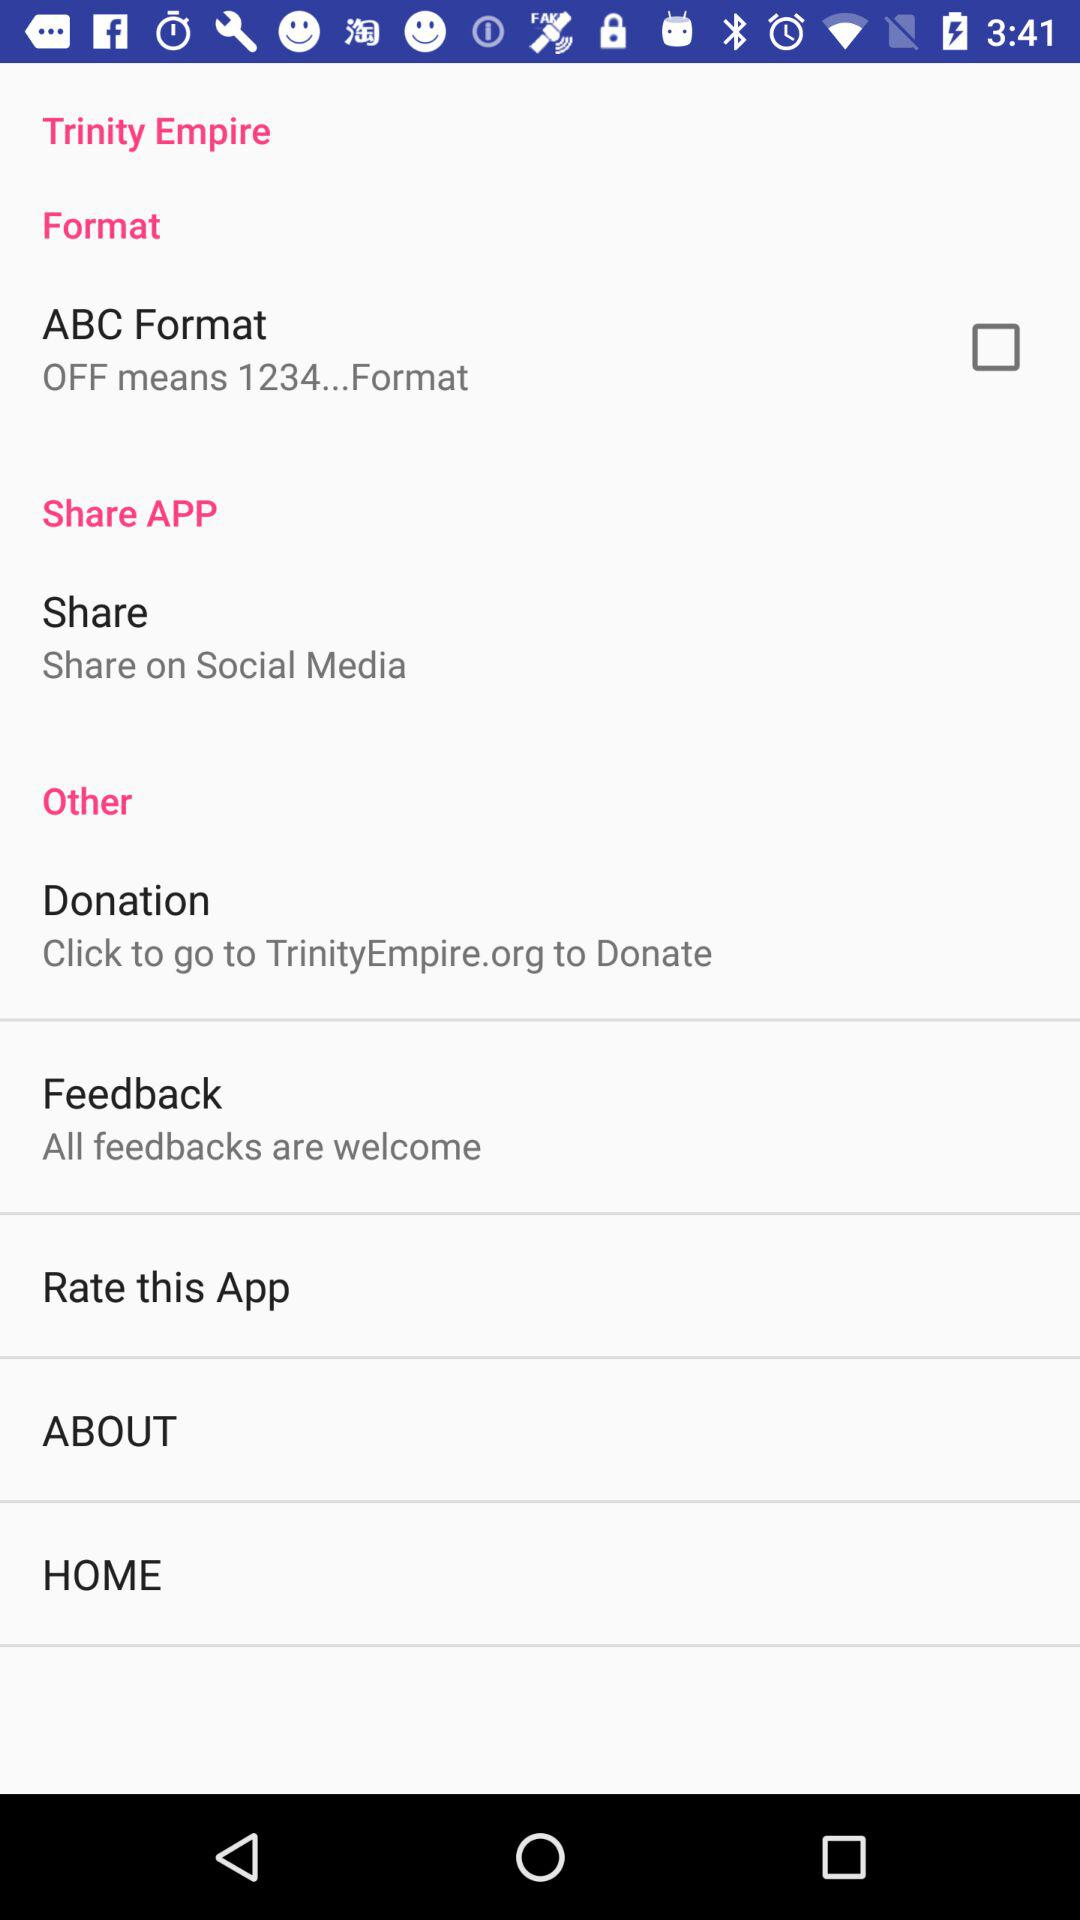Where can the application be shared? The application can be shared on "Social Media". 